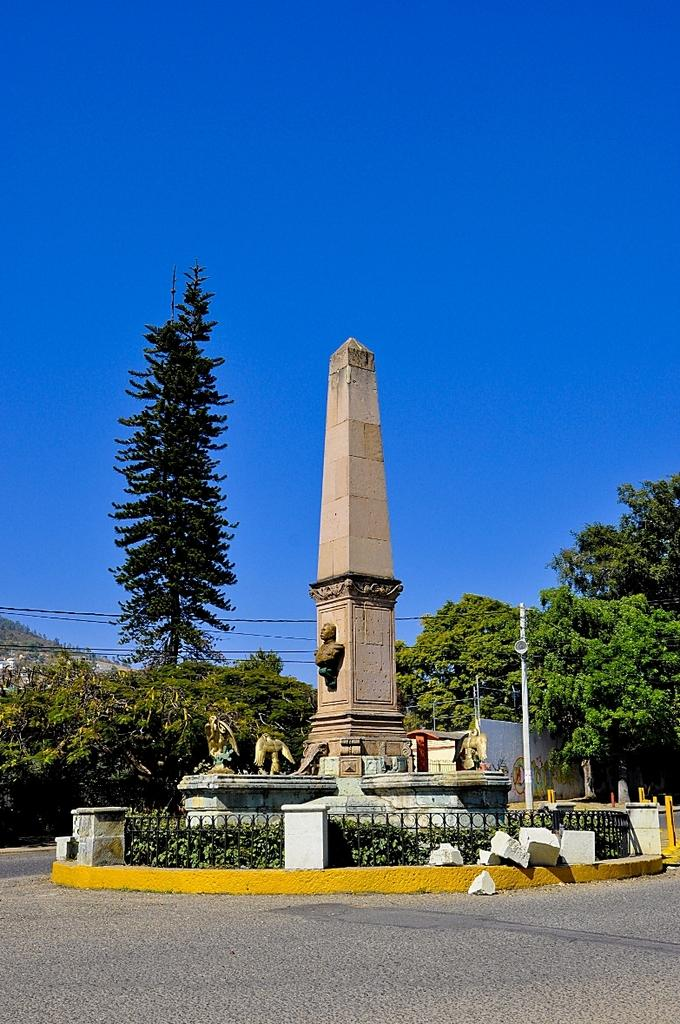What is the main structure in the image? There is a pillar in the image. What decorative elements can be seen in the image? There are sculptures in the image. What type of vegetation is present in the image? There are plants and trees in the image. What architectural features can be observed in the image? There are iron grilles in the image. What natural elements are present in the image? There are rocks in the image. What man-made feature is visible in the image? There is a road in the image. What additional architectural elements can be seen in the image? There are cables in the image. What can be seen in the background of the image? The sky is visible in the background of the image. What type of veil is draped over the pillar in the image? There is no veil present in the image; it only features a pillar, sculptures, plants, iron grilles, rocks, a road, cables, and the sky in the background. 